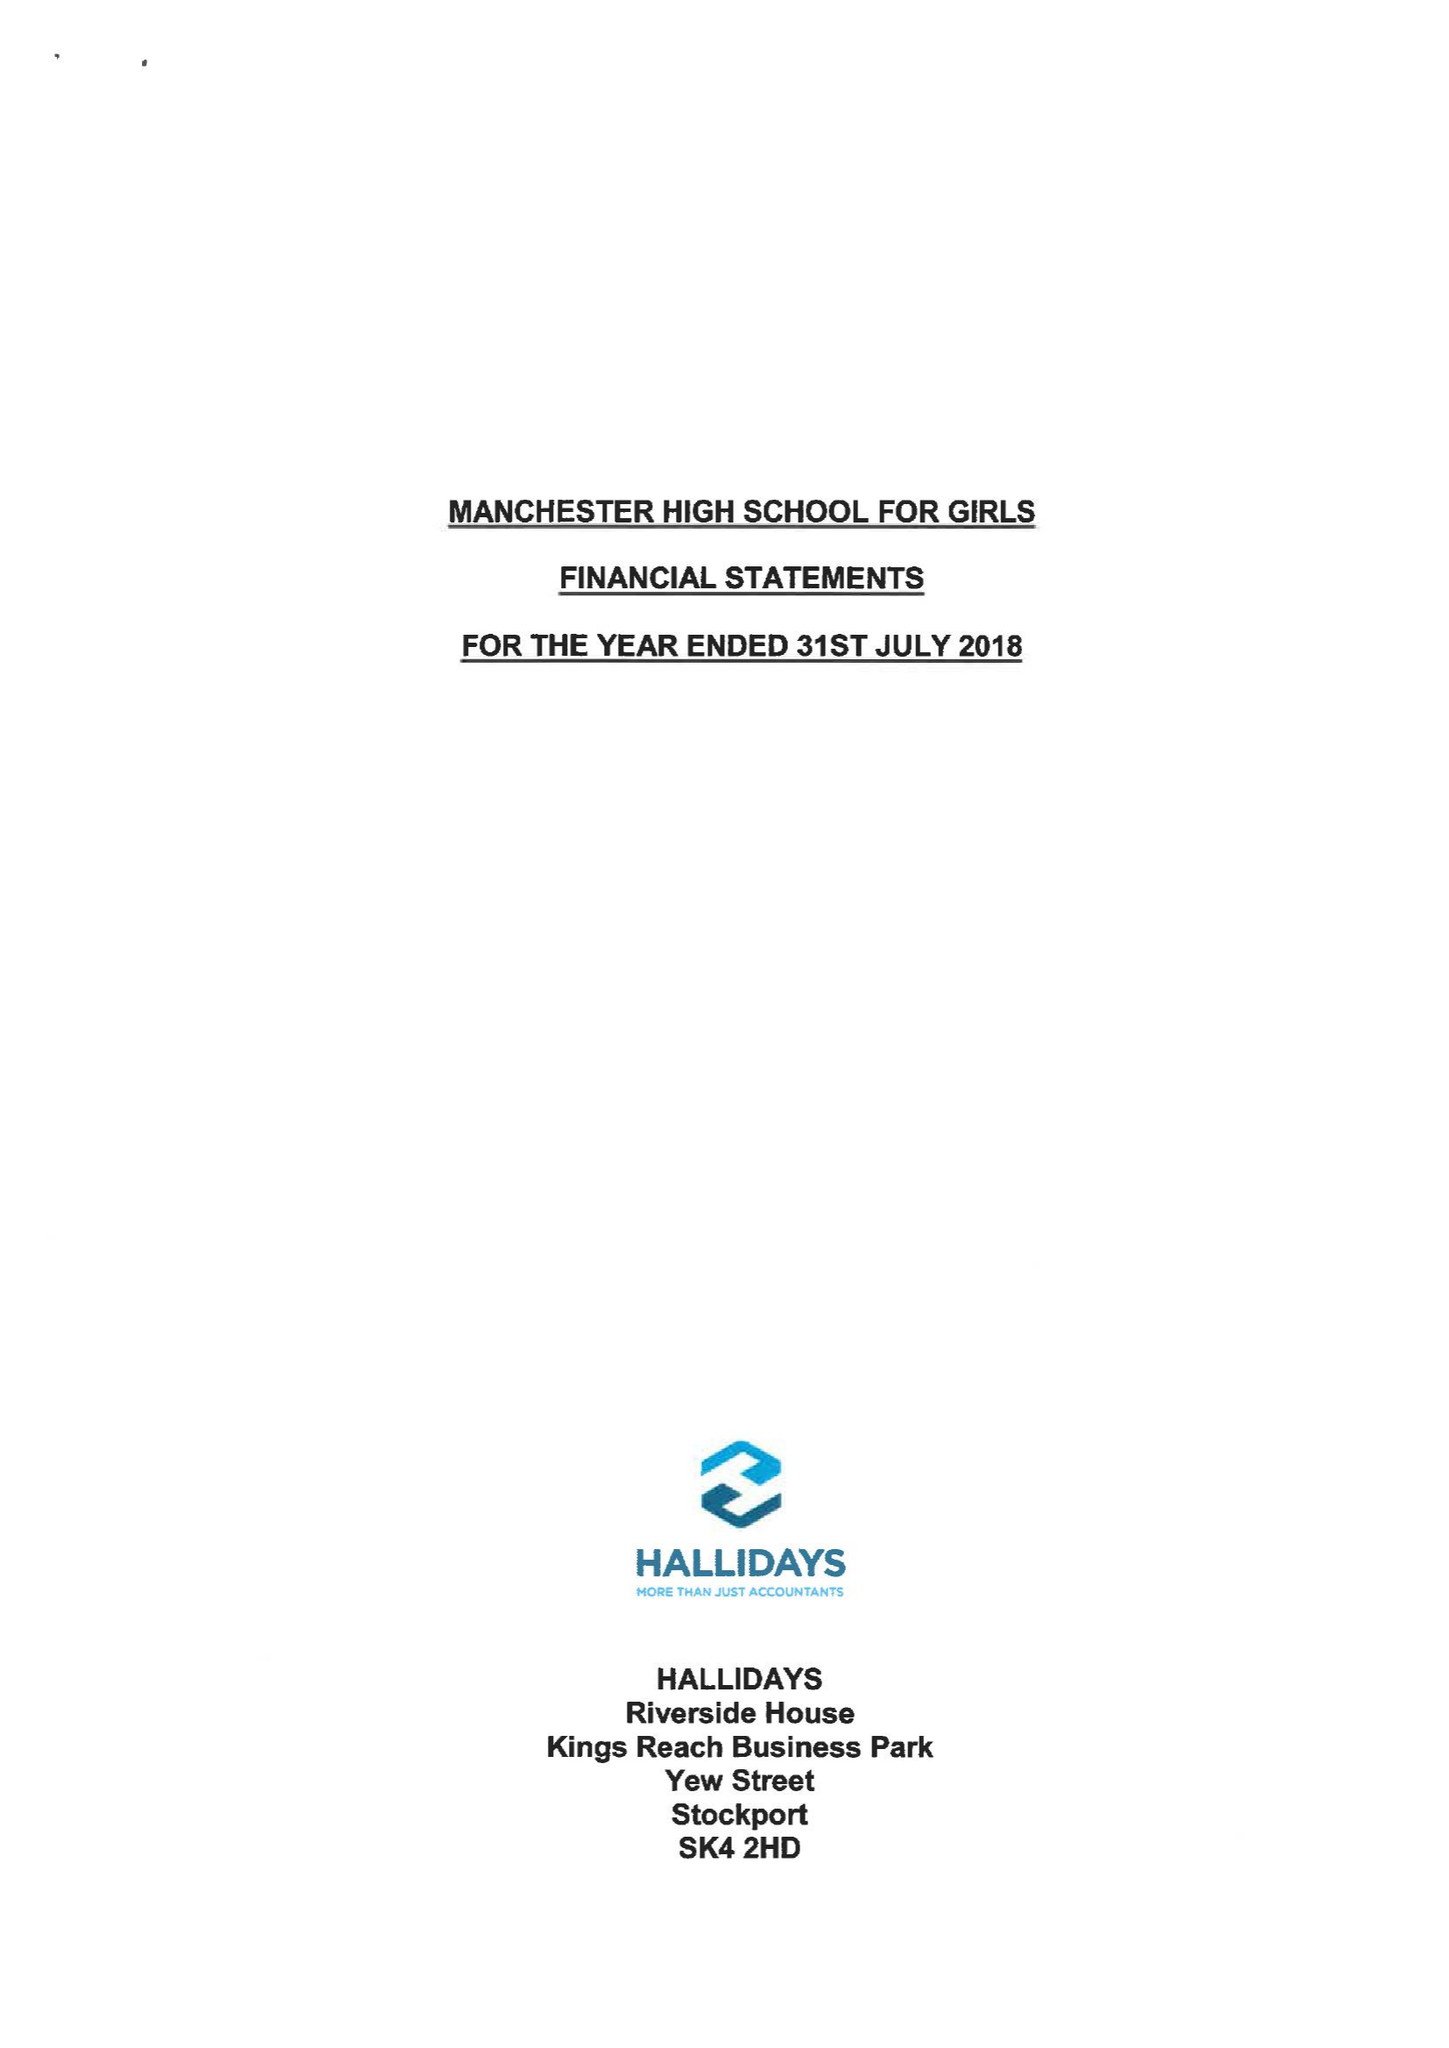What is the value for the spending_annually_in_british_pounds?
Answer the question using a single word or phrase. 10359729.00 